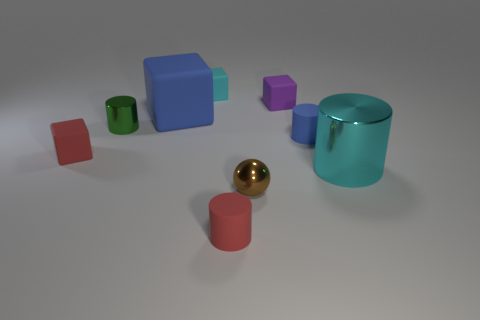Is there a small red matte cylinder?
Provide a short and direct response. Yes. Is the shape of the tiny cyan rubber object the same as the green object?
Your response must be concise. No. There is a small rubber block that is on the left side of the large thing that is behind the large cylinder; what number of cyan cubes are to the right of it?
Your answer should be very brief. 1. What is the tiny cylinder that is behind the small ball and in front of the green cylinder made of?
Your answer should be very brief. Rubber. What is the color of the tiny cylinder that is both behind the small red cylinder and on the right side of the green thing?
Your answer should be compact. Blue. Is there anything else of the same color as the small ball?
Your answer should be compact. No. There is a matte thing in front of the cyan thing that is in front of the rubber cylinder that is to the right of the purple thing; what is its shape?
Provide a succinct answer. Cylinder. There is another big object that is the same shape as the purple thing; what is its color?
Ensure brevity in your answer.  Blue. There is a matte cylinder on the left side of the blue thing in front of the green object; what is its color?
Your answer should be compact. Red. There is a blue object that is the same shape as the green object; what is its size?
Your response must be concise. Small. 